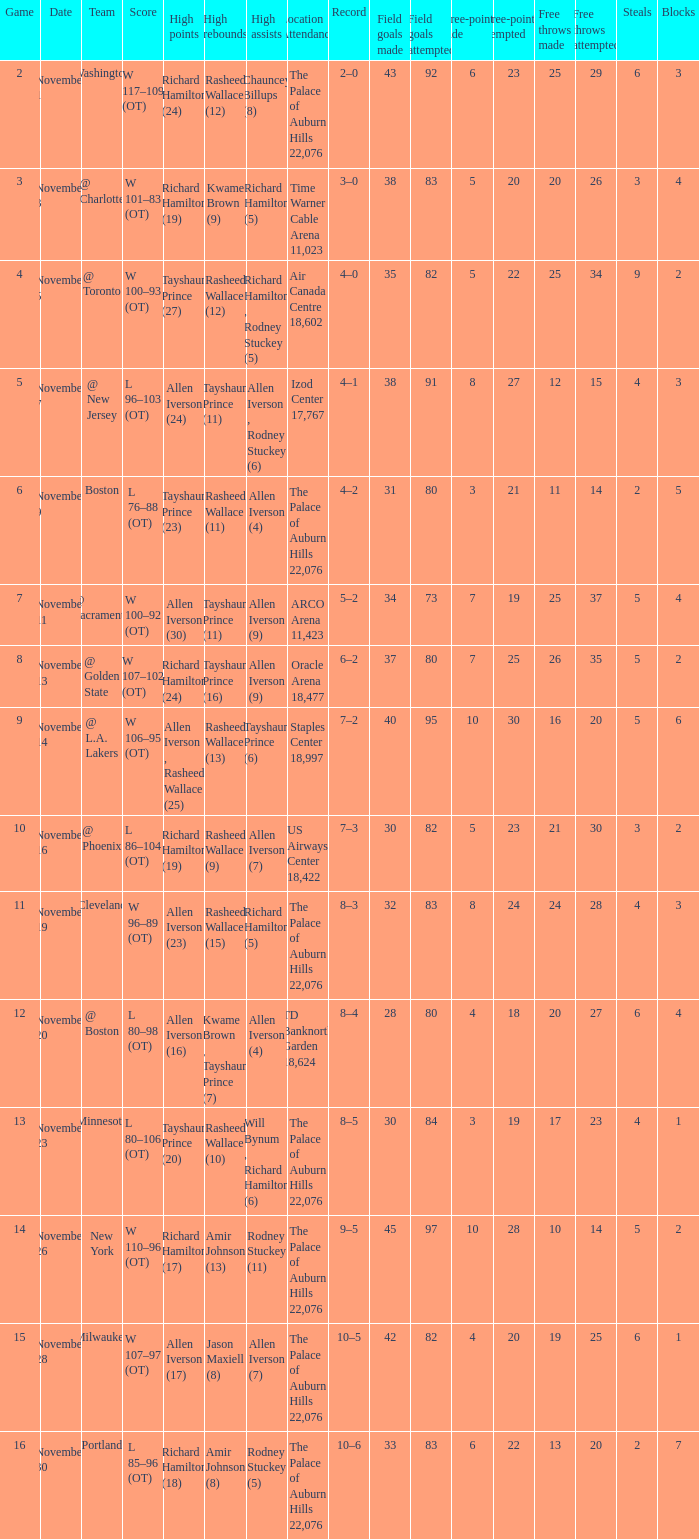What is High Points, when Game is less than 10, and when High Assists is "Chauncey Billups (8)"? Richard Hamilton (24). 